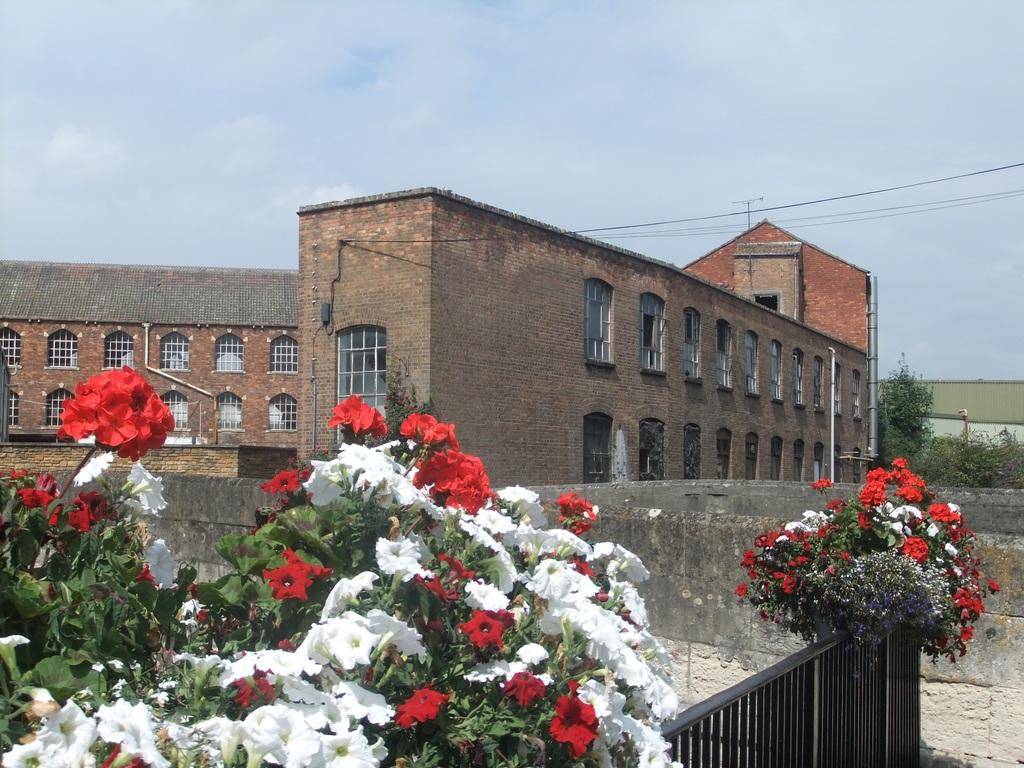What can be seen in the foreground of the picture? In the foreground of the picture, there are flowers, a gate, and a wall. What is located in the center of the picture? In the center of the picture, there are trees, buildings, and cables. What is visible in the background of the picture? The background of the picture is the sky. Can you tell me how many toothbrushes are hanging from the trees in the center of the picture? There are no toothbrushes present in the image; it features trees, buildings, and cables. What type of sand can be seen on the wall in the foreground of the picture? There is no sand present on the wall in the foreground of the picture; it is a solid structure. 